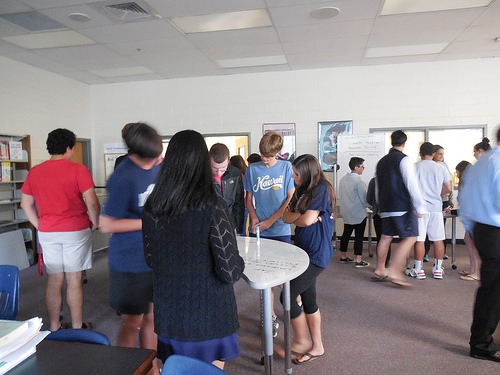<image>
Is there a boy to the left of the girl? Yes. From this viewpoint, the boy is positioned to the left side relative to the girl. Is the boy to the right of the girl? No. The boy is not to the right of the girl. The horizontal positioning shows a different relationship. 